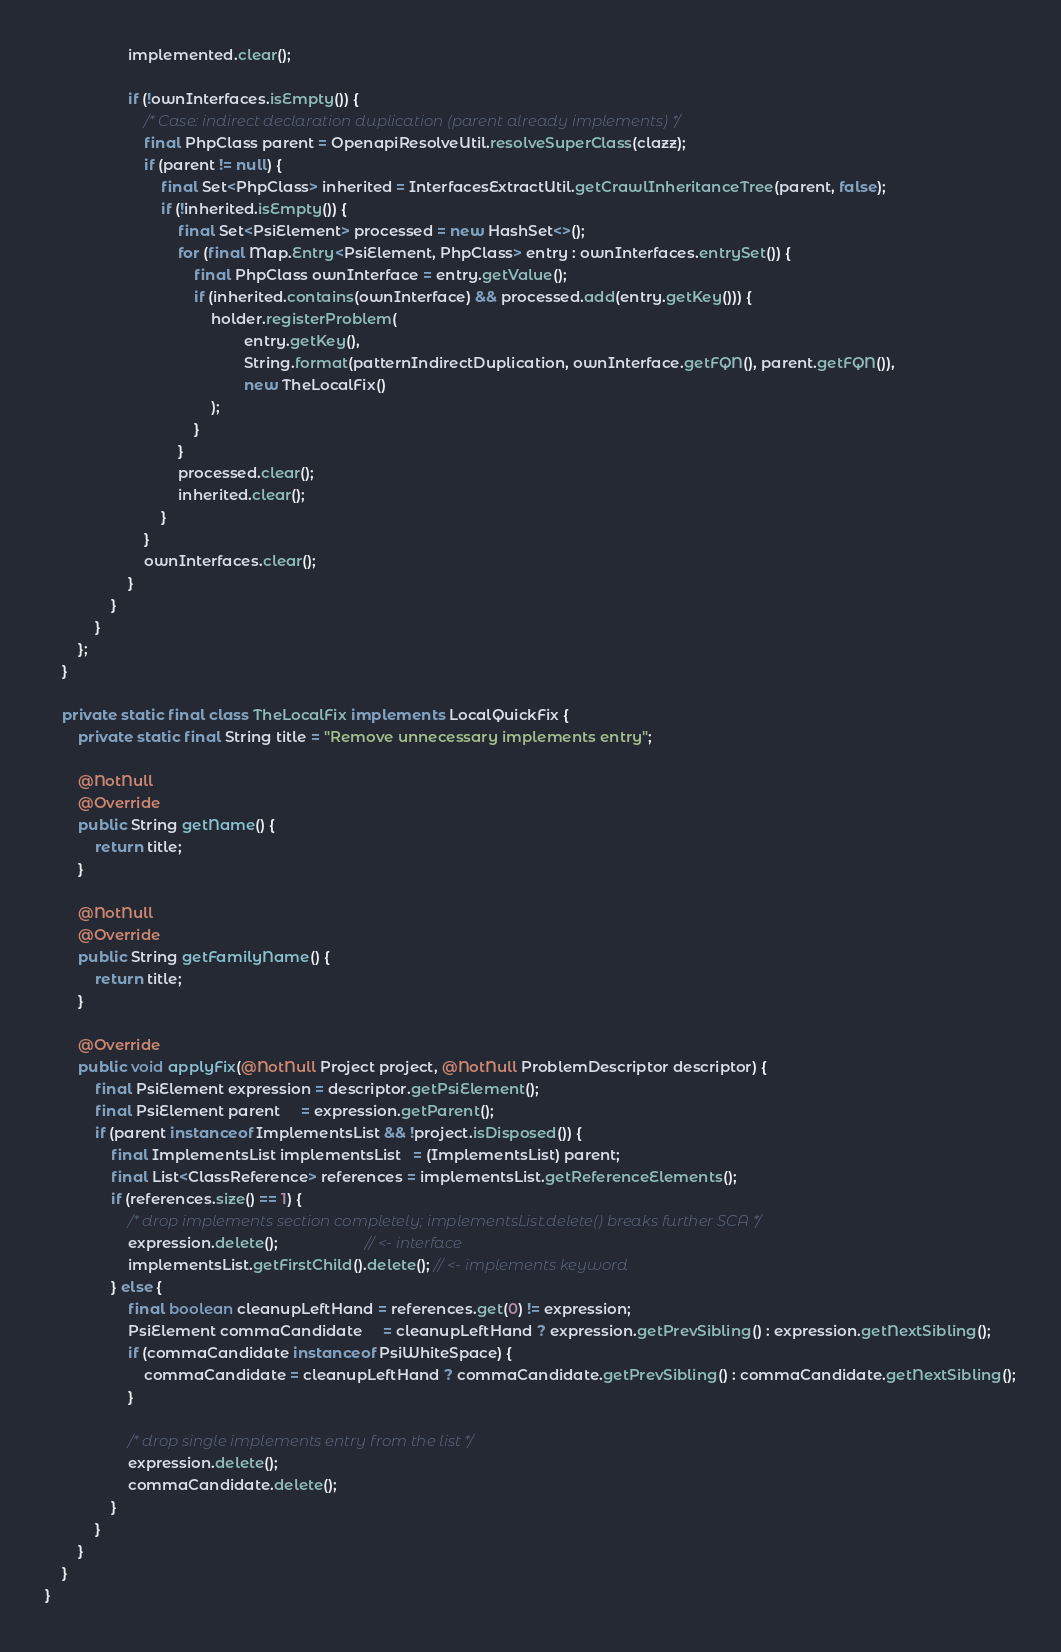<code> <loc_0><loc_0><loc_500><loc_500><_Java_>                    implemented.clear();

                    if (!ownInterfaces.isEmpty()) {
                        /* Case: indirect declaration duplication (parent already implements) */
                        final PhpClass parent = OpenapiResolveUtil.resolveSuperClass(clazz);
                        if (parent != null) {
                            final Set<PhpClass> inherited = InterfacesExtractUtil.getCrawlInheritanceTree(parent, false);
                            if (!inherited.isEmpty()) {
                                final Set<PsiElement> processed = new HashSet<>();
                                for (final Map.Entry<PsiElement, PhpClass> entry : ownInterfaces.entrySet()) {
                                    final PhpClass ownInterface = entry.getValue();
                                    if (inherited.contains(ownInterface) && processed.add(entry.getKey())) {
                                        holder.registerProblem(
                                                entry.getKey(),
                                                String.format(patternIndirectDuplication, ownInterface.getFQN(), parent.getFQN()),
                                                new TheLocalFix()
                                        );
                                    }
                                }
                                processed.clear();
                                inherited.clear();
                            }
                        }
                        ownInterfaces.clear();
                    }
                }
            }
        };
    }

    private static final class TheLocalFix implements LocalQuickFix {
        private static final String title = "Remove unnecessary implements entry";

        @NotNull
        @Override
        public String getName() {
            return title;
        }

        @NotNull
        @Override
        public String getFamilyName() {
            return title;
        }

        @Override
        public void applyFix(@NotNull Project project, @NotNull ProblemDescriptor descriptor) {
            final PsiElement expression = descriptor.getPsiElement();
            final PsiElement parent     = expression.getParent();
            if (parent instanceof ImplementsList && !project.isDisposed()) {
                final ImplementsList implementsList   = (ImplementsList) parent;
                final List<ClassReference> references = implementsList.getReferenceElements();
                if (references.size() == 1) {
                    /* drop implements section completely; implementsList.delete() breaks further SCA */
                    expression.delete();                     // <- interface
                    implementsList.getFirstChild().delete(); // <- implements keyword
                } else {
                    final boolean cleanupLeftHand = references.get(0) != expression;
                    PsiElement commaCandidate     = cleanupLeftHand ? expression.getPrevSibling() : expression.getNextSibling();
                    if (commaCandidate instanceof PsiWhiteSpace) {
                        commaCandidate = cleanupLeftHand ? commaCandidate.getPrevSibling() : commaCandidate.getNextSibling();
                    }

                    /* drop single implements entry from the list */
                    expression.delete();
                    commaCandidate.delete();
                }
            }
        }
    }
}</code> 